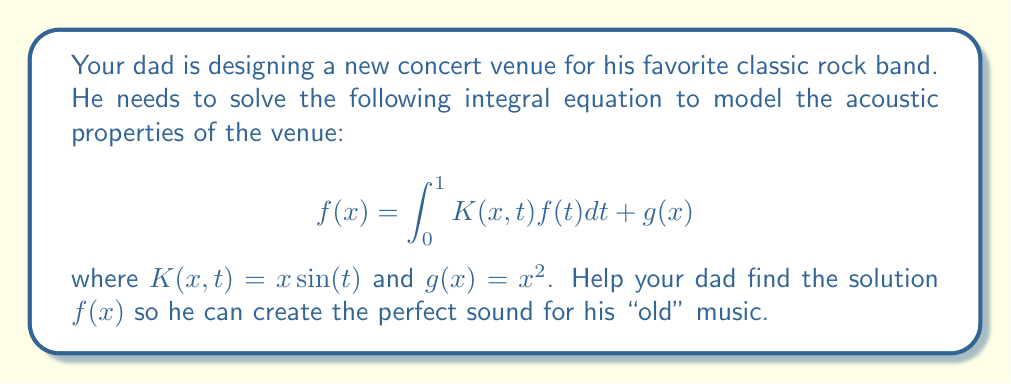Give your solution to this math problem. Let's solve this step-by-step:

1) We start with the integral equation:
   $$f(x) = \int_0^1 x\sin(t)f(t)dt + x^2$$

2) Notice that $f(x)$ appears on both sides. We can simplify by taking $x$ out of the integral:
   $$f(x) = x\int_0^1 \sin(t)f(t)dt + x^2$$

3) Let's define a constant $C$ to represent the integral:
   $$C = \int_0^1 \sin(t)f(t)dt$$

4) Now our equation becomes:
   $$f(x) = Cx + x^2$$

5) To find $C$, we can substitute this back into the integral:
   $$C = \int_0^1 \sin(t)(Ct + t^2)dt$$

6) Expanding the integral:
   $$C = C\int_0^1 t\sin(t)dt + \int_0^1 t^2\sin(t)dt$$

7) These integrals can be solved using integration by parts:
   $$\int_0^1 t\sin(t)dt = \sin(1) - 1$$
   $$\int_0^1 t^2\sin(t)dt = 2\sin(1) - 2\cos(1)$$

8) Substituting back:
   $$C = C(\sin(1) - 1) + (2\sin(1) - 2\cos(1))$$

9) Solving for $C$:
   $$C(2-\sin(1)) = 2\sin(1) - 2\cos(1)$$
   $$C = \frac{2\sin(1) - 2\cos(1)}{2-\sin(1)}$$

10) Therefore, the final solution is:
    $$f(x) = \frac{2\sin(1) - 2\cos(1)}{2-\sin(1)}x + x^2$$
Answer: $f(x) = \frac{2\sin(1) - 2\cos(1)}{2-\sin(1)}x + x^2$ 